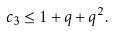Convert formula to latex. <formula><loc_0><loc_0><loc_500><loc_500>c _ { 3 } \leq 1 + q + q ^ { 2 } .</formula> 